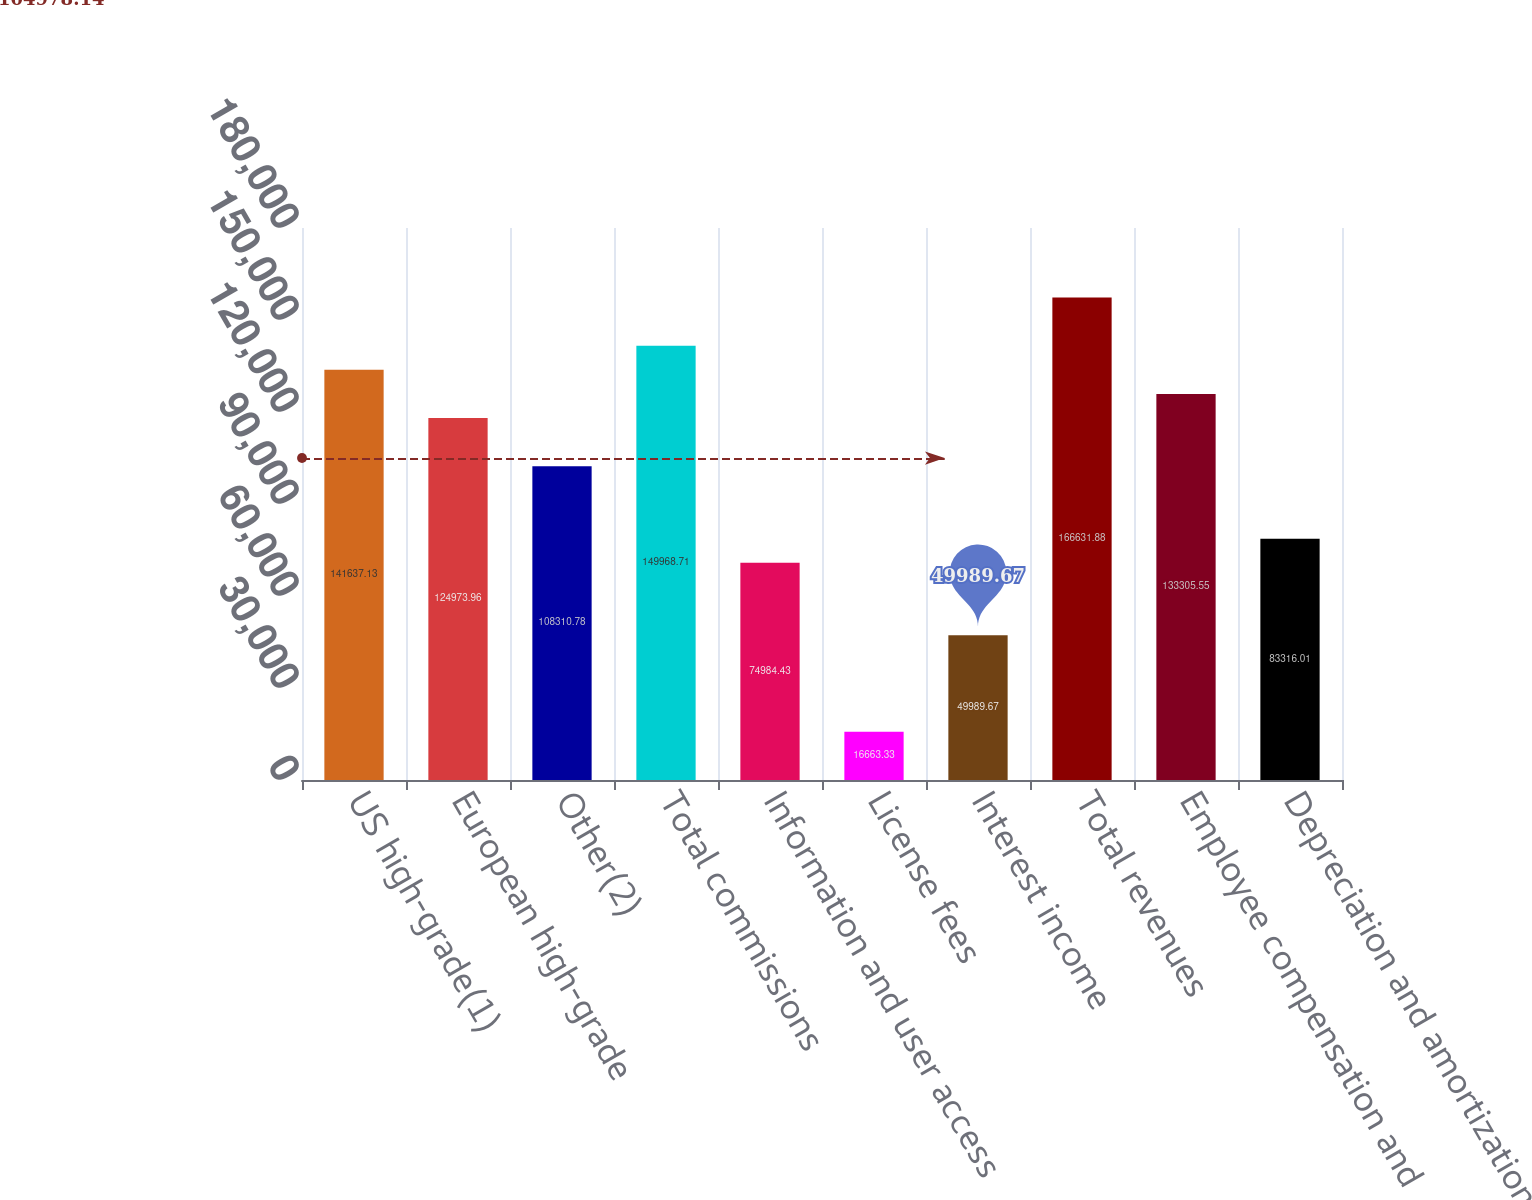Convert chart to OTSL. <chart><loc_0><loc_0><loc_500><loc_500><bar_chart><fcel>US high-grade(1)<fcel>European high-grade<fcel>Other(2)<fcel>Total commissions<fcel>Information and user access<fcel>License fees<fcel>Interest income<fcel>Total revenues<fcel>Employee compensation and<fcel>Depreciation and amortization<nl><fcel>141637<fcel>124974<fcel>108311<fcel>149969<fcel>74984.4<fcel>16663.3<fcel>49989.7<fcel>166632<fcel>133306<fcel>83316<nl></chart> 